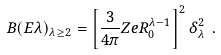<formula> <loc_0><loc_0><loc_500><loc_500>B ( E \lambda ) _ { \lambda \geq 2 } = \left [ { \frac { 3 } { 4 \pi } } Z e R _ { 0 } ^ { \lambda - 1 } \right ] ^ { 2 } \delta _ { \lambda } ^ { 2 } \ .</formula> 